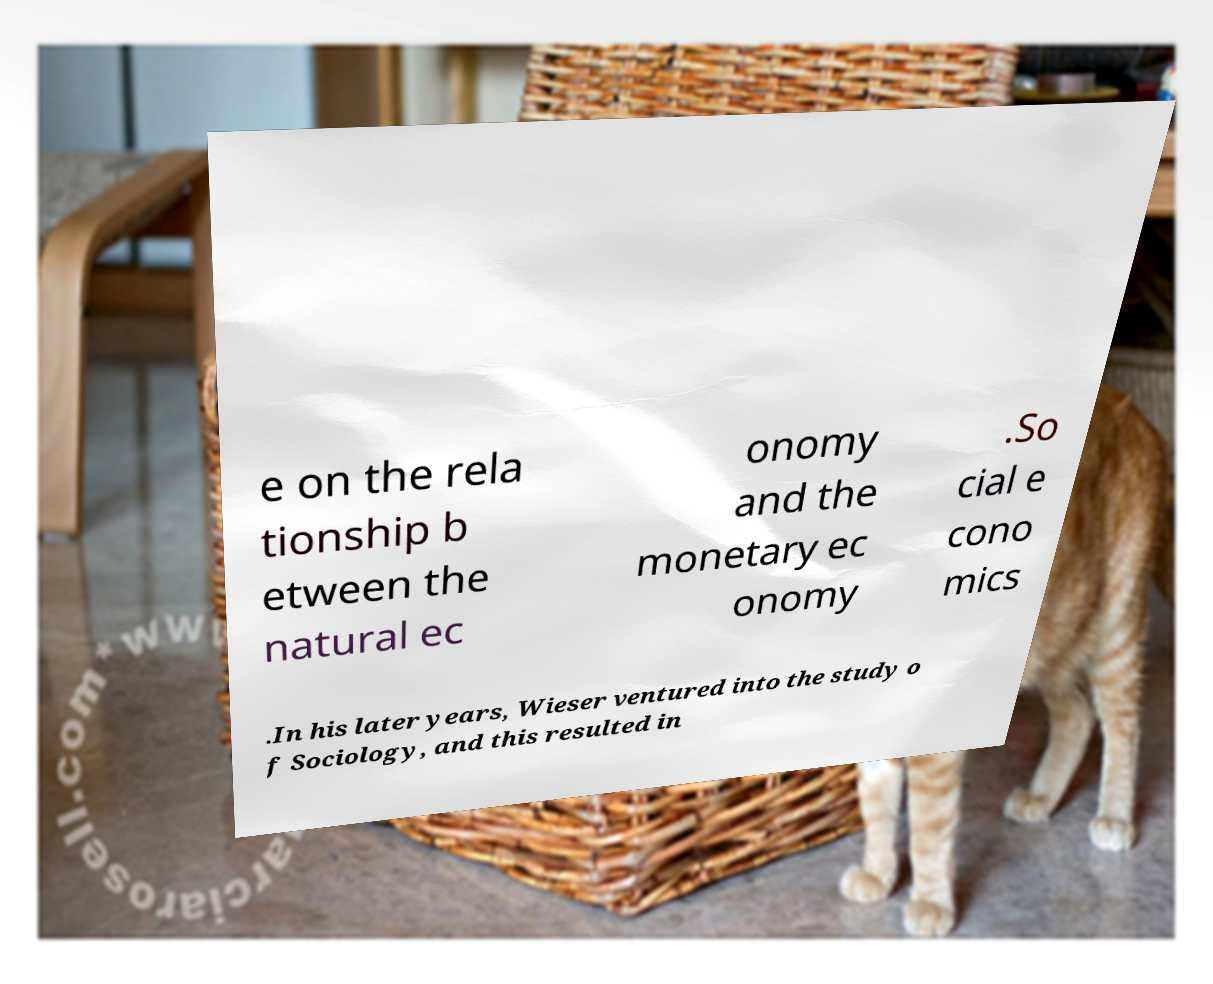There's text embedded in this image that I need extracted. Can you transcribe it verbatim? e on the rela tionship b etween the natural ec onomy and the monetary ec onomy .So cial e cono mics .In his later years, Wieser ventured into the study o f Sociology, and this resulted in 